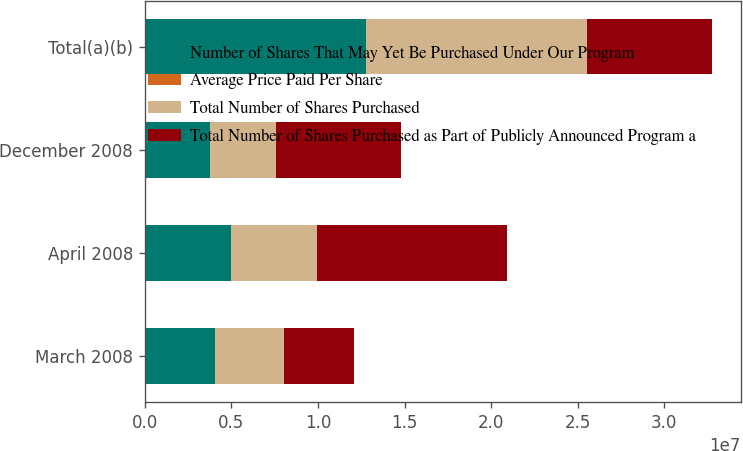Convert chart to OTSL. <chart><loc_0><loc_0><loc_500><loc_500><stacked_bar_chart><ecel><fcel>March 2008<fcel>April 2008<fcel>December 2008<fcel>Total(a)(b)<nl><fcel>Number of Shares That May Yet Be Purchased Under Our Program<fcel>4.0282e+06<fcel>4.9718e+06<fcel>3.7775e+06<fcel>1.27775e+07<nl><fcel>Average Price Paid Per Share<fcel>59.61<fcel>64.27<fcel>47.41<fcel>57.82<nl><fcel>Total Number of Shares Purchased<fcel>4.0282e+06<fcel>4.9718e+06<fcel>3.7775e+06<fcel>1.27775e+07<nl><fcel>Total Number of Shares Purchased as Part of Publicly Announced Program a<fcel>4.0282e+06<fcel>1.1e+07<fcel>7.2225e+06<fcel>7.2225e+06<nl></chart> 